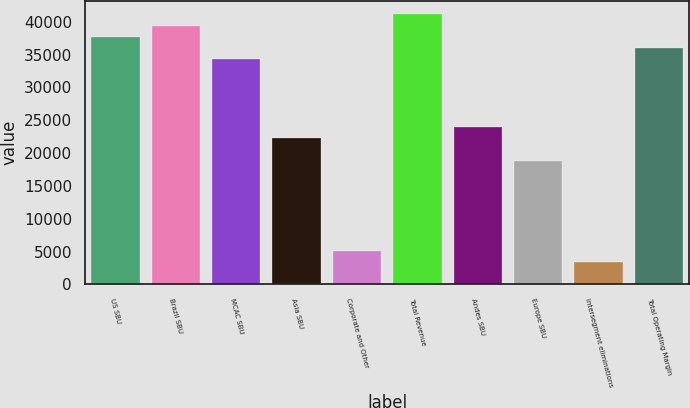Convert chart. <chart><loc_0><loc_0><loc_500><loc_500><bar_chart><fcel>US SBU<fcel>Brazil SBU<fcel>MCAC SBU<fcel>Asia SBU<fcel>Corporate and Other<fcel>Total Revenue<fcel>Andes SBU<fcel>Europe SBU<fcel>Intersegment eliminations<fcel>Total Operating Margin<nl><fcel>37720.9<fcel>39435.5<fcel>34291.8<fcel>22289.7<fcel>5143.98<fcel>41150.1<fcel>24004.3<fcel>18860.6<fcel>3429.4<fcel>36006.4<nl></chart> 